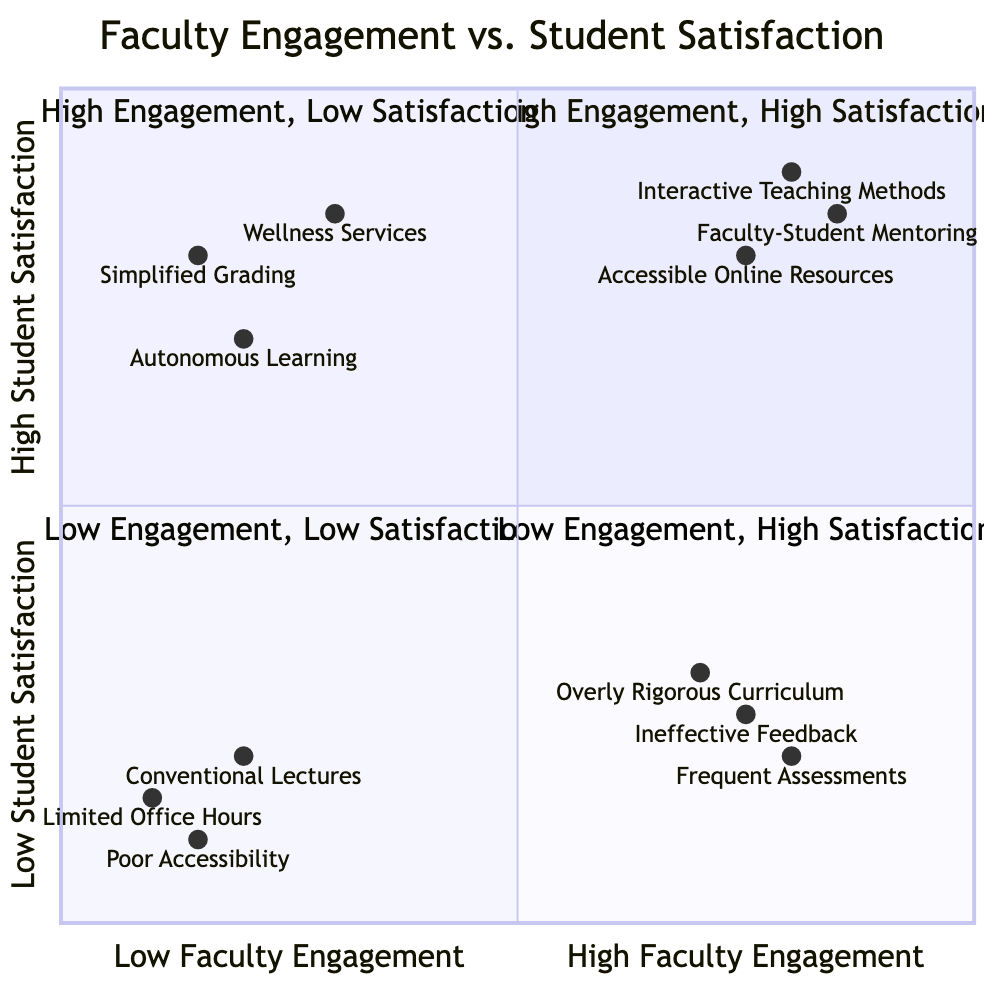What type of teaching method is found in the High Engagement, High Satisfaction quadrant? The High Engagement, High Satisfaction quadrant includes "Interactive Teaching Methods," which refers to utilizing active learning techniques to engage students.
Answer: Interactive Teaching Methods How many elements are associated with the Low Engagement, Low Satisfaction quadrant? The Low Engagement, Low Satisfaction quadrant contains three elements: Conventional Lecture-Based Instruction, Limited Office Hours, and Poor Accessibility Features.
Answer: 3 Which quadrant has elements related to rigorous academic challenges? The High Engagement, Low Satisfaction quadrant features elements like Overly Rigorous Curriculum and Frequent Assessments, both of which relate to rigorous academic challenges.
Answer: High Engagement, Low Satisfaction What is the description of Accessible Online Resources? Accessible Online Resources are described as ensuring teaching materials are available and easily accessible on platforms like Canvas.
Answer: Ensuring teaching materials are available and easily accessible on platforms like Canvas Which entity is associated with low student burnout? Autonomous Learning Opportunities, which refer to self-paced courses like those offered by Coursera or Khan Academy, are associated with low student burnout since they allow students to learn at their own pace.
Answer: Autonomous Learning Opportunities In which quadrant is the feedback mechanism considered ineffective? The High Engagement, Low Satisfaction quadrant contains the element "Ineffective Feedback Mechanisms," indicating that feedback processes are poorly implemented despite high faculty engagement.
Answer: High Engagement, Low Satisfaction What percentage of elements in the Low Faculty Engagement, High Student Satisfaction quadrant are focused on student support? Two out of three elements in the Low Faculty Engagement, High Student Satisfaction quadrant are focused on student support: Simplified Grading Standards and Wellness and Support Services. Therefore, the percentage is approximately 66.67%.
Answer: 66.67% Which teaching method is found in the Low Engagement, High Satisfaction quadrant? The Low Engagement, High Satisfaction quadrant contains "Autonomous Learning Opportunities," which promote self-directed learning through platforms like Coursera.
Answer: Autonomous Learning Opportunities 